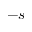<formula> <loc_0><loc_0><loc_500><loc_500>- s</formula> 